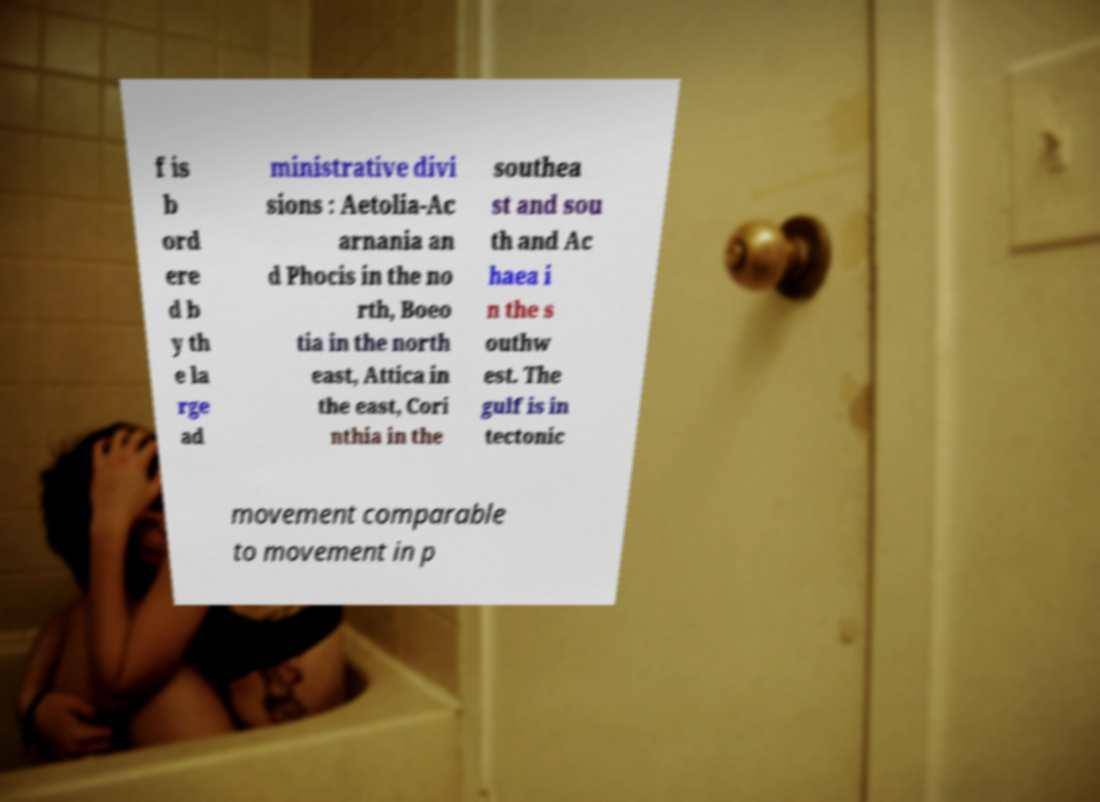I need the written content from this picture converted into text. Can you do that? f is b ord ere d b y th e la rge ad ministrative divi sions : Aetolia-Ac arnania an d Phocis in the no rth, Boeo tia in the north east, Attica in the east, Cori nthia in the southea st and sou th and Ac haea i n the s outhw est. The gulf is in tectonic movement comparable to movement in p 